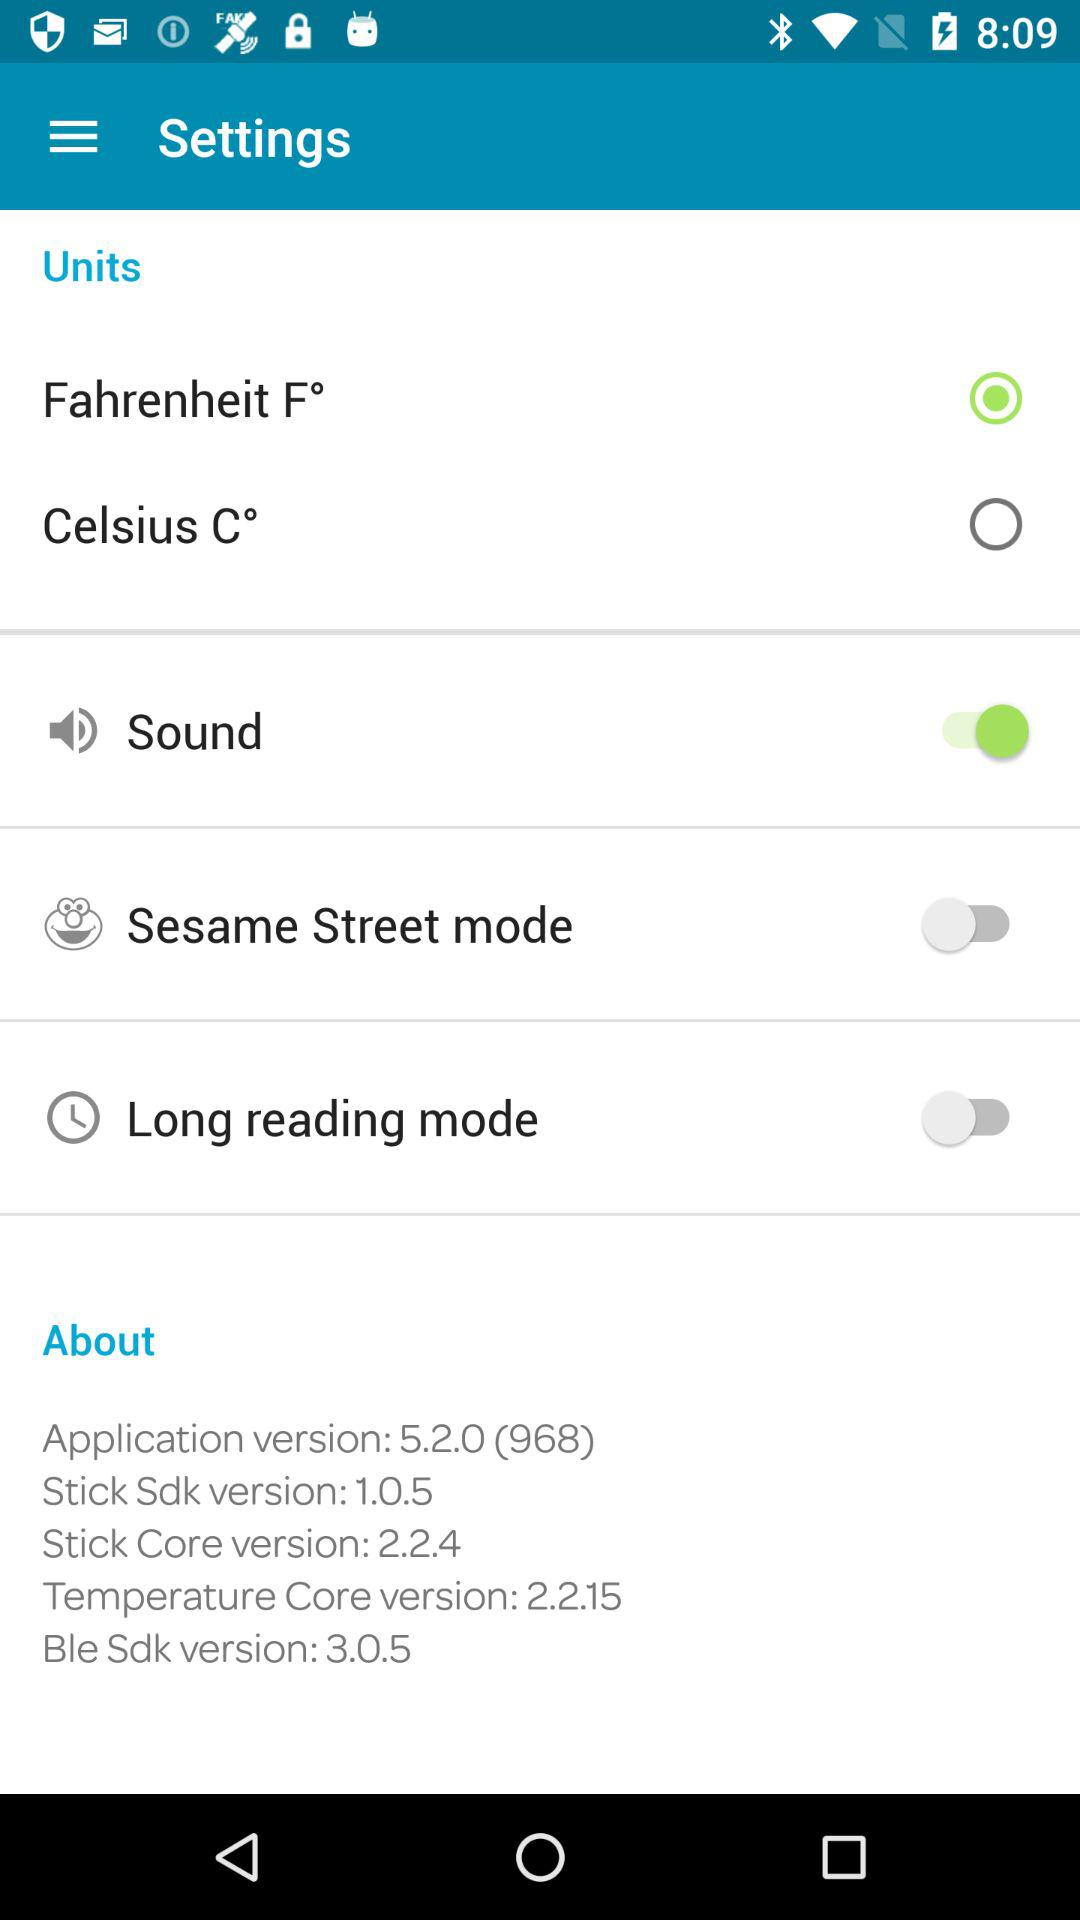What is the application version being used? The application version is 5.2.0 (968). 